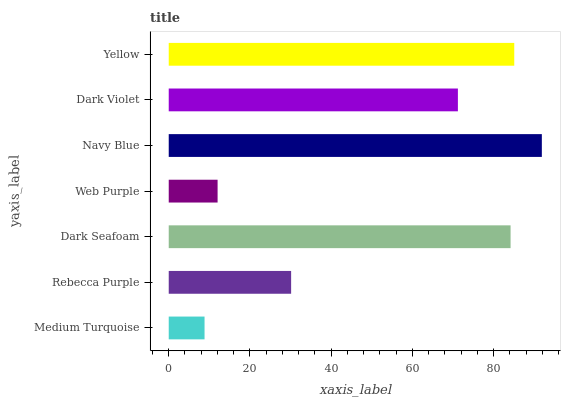Is Medium Turquoise the minimum?
Answer yes or no. Yes. Is Navy Blue the maximum?
Answer yes or no. Yes. Is Rebecca Purple the minimum?
Answer yes or no. No. Is Rebecca Purple the maximum?
Answer yes or no. No. Is Rebecca Purple greater than Medium Turquoise?
Answer yes or no. Yes. Is Medium Turquoise less than Rebecca Purple?
Answer yes or no. Yes. Is Medium Turquoise greater than Rebecca Purple?
Answer yes or no. No. Is Rebecca Purple less than Medium Turquoise?
Answer yes or no. No. Is Dark Violet the high median?
Answer yes or no. Yes. Is Dark Violet the low median?
Answer yes or no. Yes. Is Web Purple the high median?
Answer yes or no. No. Is Rebecca Purple the low median?
Answer yes or no. No. 